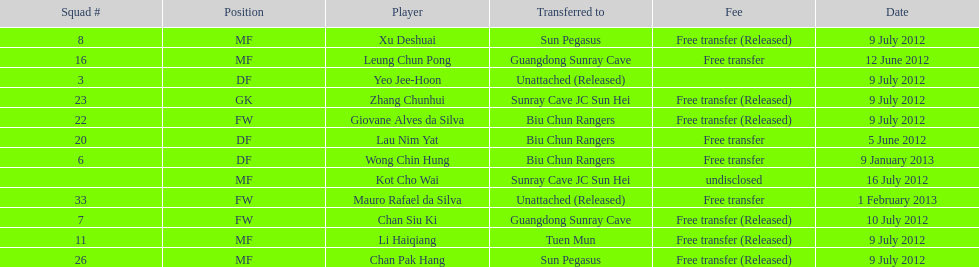What position is next to squad # 3? DF. 